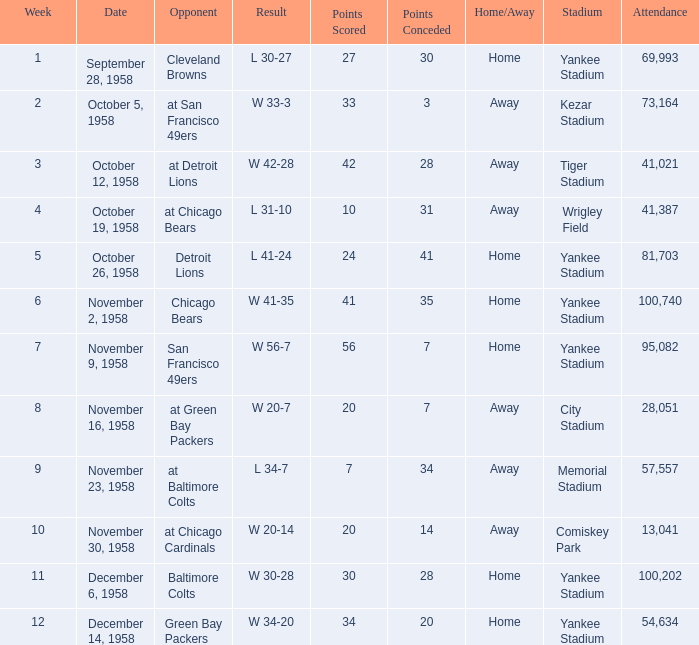What was the higest attendance on November 9, 1958? 95082.0. 